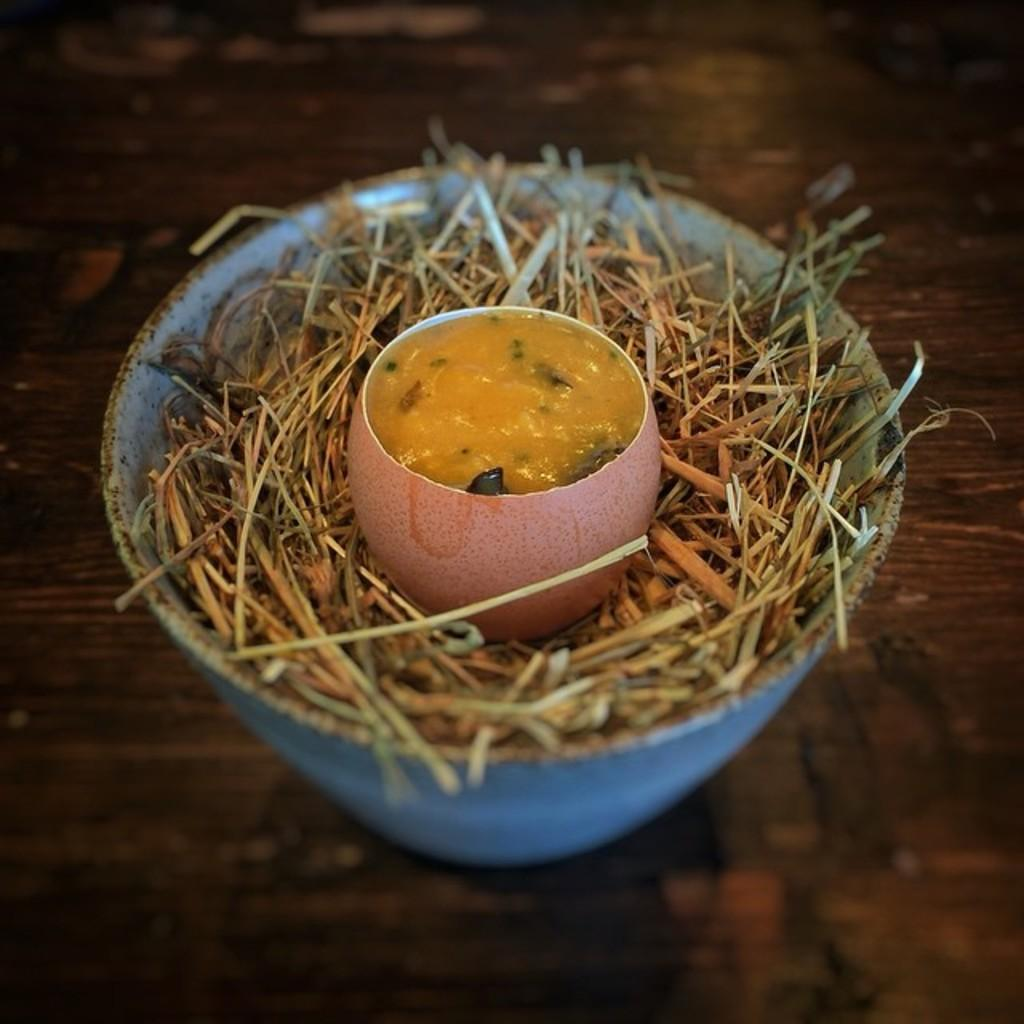What color is the bowl in the image? The bowl in the image is blue. What is the bowl placed on? The bowl is on a brown color table. What is inside the blue bowl? There are sticks in the blue bowl. What is the purpose of the sticks in the blue bowl? The sticks are used to hold another bowl. What is in the bowl that is placed on the sticks? The bowl on the sticks contains food. Can you tell me how the oatmeal joins the sticks in the image? There is no oatmeal present in the image, and therefore no such interaction can be observed. 